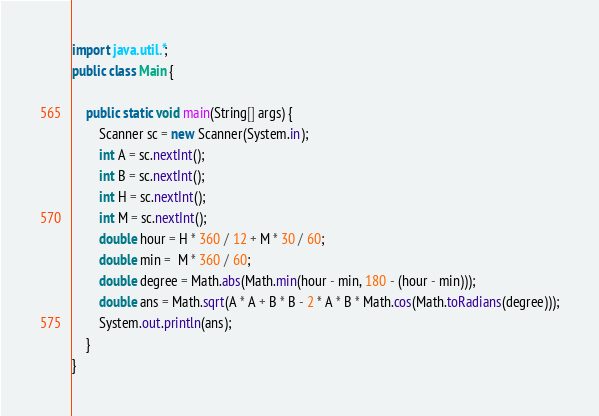<code> <loc_0><loc_0><loc_500><loc_500><_Java_>import java.util.*;
public class Main {

    public static void main(String[] args) {
        Scanner sc = new Scanner(System.in);
        int A = sc.nextInt();
        int B = sc.nextInt();
        int H = sc.nextInt();
        int M = sc.nextInt();
        double hour = H * 360 / 12 + M * 30 / 60;
        double min =  M * 360 / 60;
        double degree = Math.abs(Math.min(hour - min, 180 - (hour - min)));
        double ans = Math.sqrt(A * A + B * B - 2 * A * B * Math.cos(Math.toRadians(degree)));
        System.out.println(ans);
    }
}</code> 